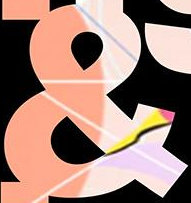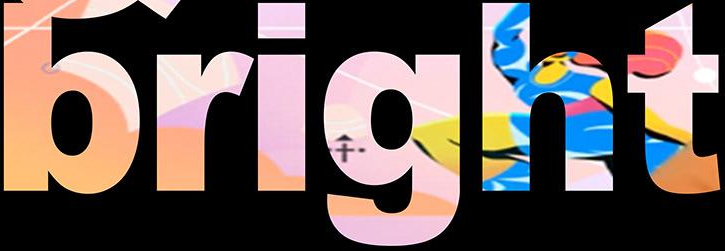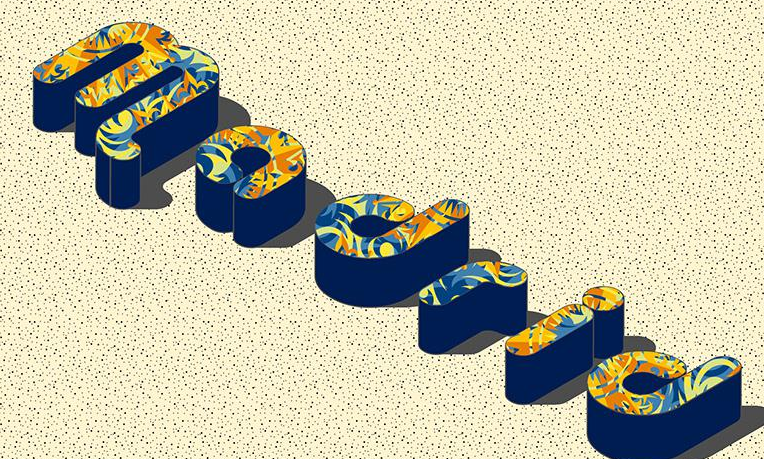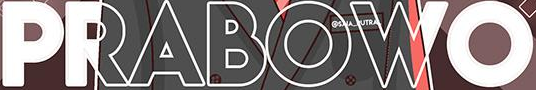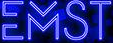What text appears in these images from left to right, separated by a semicolon? &; bright; Madrid; PRABOWO; EMST 